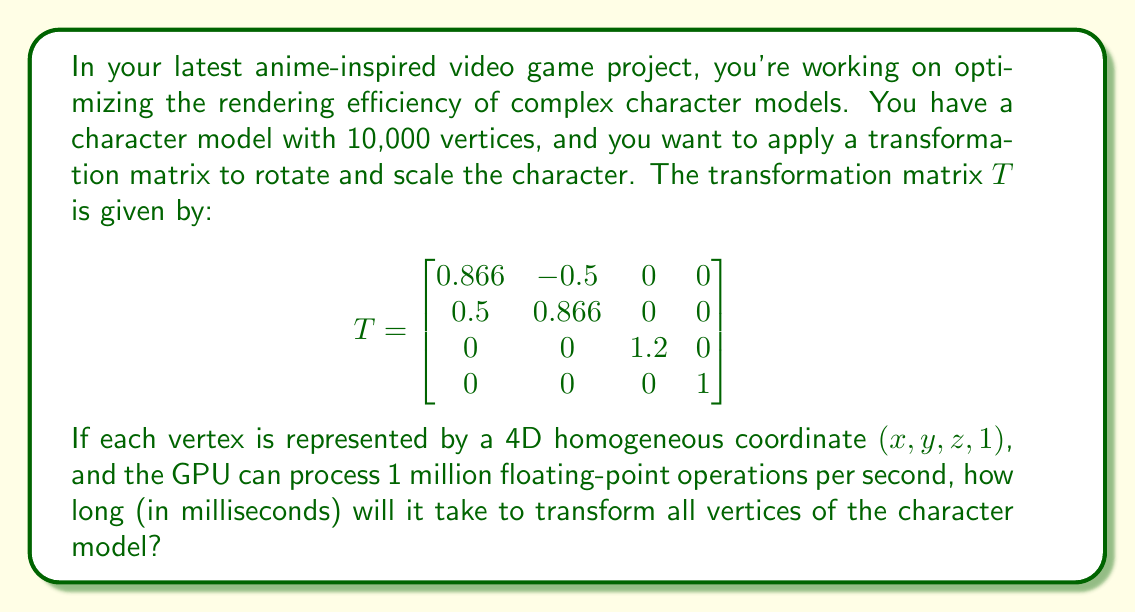Teach me how to tackle this problem. Let's break this down step-by-step:

1) First, we need to calculate how many floating-point operations are required to transform a single vertex.

   - Multiplying a 4x4 matrix by a 4x1 vector requires 16 multiplications and 12 additions.
   - Total operations per vertex = 16 + 12 = 28

2) Now, we need to calculate the total number of operations for all vertices:

   - Total operations = Operations per vertex × Number of vertices
   - Total operations = 28 × 10,000 = 280,000

3) Given that the GPU can process 1 million floating-point operations per second, we can calculate the time taken:

   - Time (in seconds) = Total operations ÷ Operations per second
   - Time = 280,000 ÷ 1,000,000 = 0.28 seconds

4) Convert the time to milliseconds:

   - Time in milliseconds = 0.28 × 1000 = 280 ms

Therefore, it will take 280 milliseconds to transform all vertices of the character model.
Answer: 280 ms 